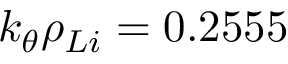<formula> <loc_0><loc_0><loc_500><loc_500>k _ { \theta } \rho _ { L i } = 0 . 2 5 5 5</formula> 